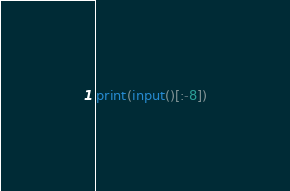<code> <loc_0><loc_0><loc_500><loc_500><_Python_>print(input()[:-8])</code> 